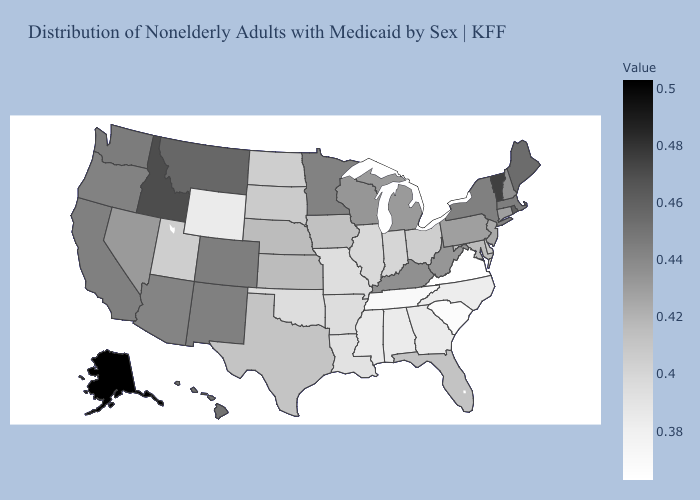Does Massachusetts have a lower value than Tennessee?
Quick response, please. No. Does Hawaii have the highest value in the USA?
Give a very brief answer. No. Among the states that border Iowa , which have the highest value?
Be succinct. Minnesota. Does Virginia have the lowest value in the South?
Concise answer only. Yes. Which states have the lowest value in the USA?
Quick response, please. Virginia. Does Arizona have the highest value in the USA?
Short answer required. No. Does Missouri have the lowest value in the MidWest?
Quick response, please. Yes. Does Wyoming have the lowest value in the West?
Quick response, please. Yes. Among the states that border West Virginia , which have the highest value?
Concise answer only. Kentucky. 